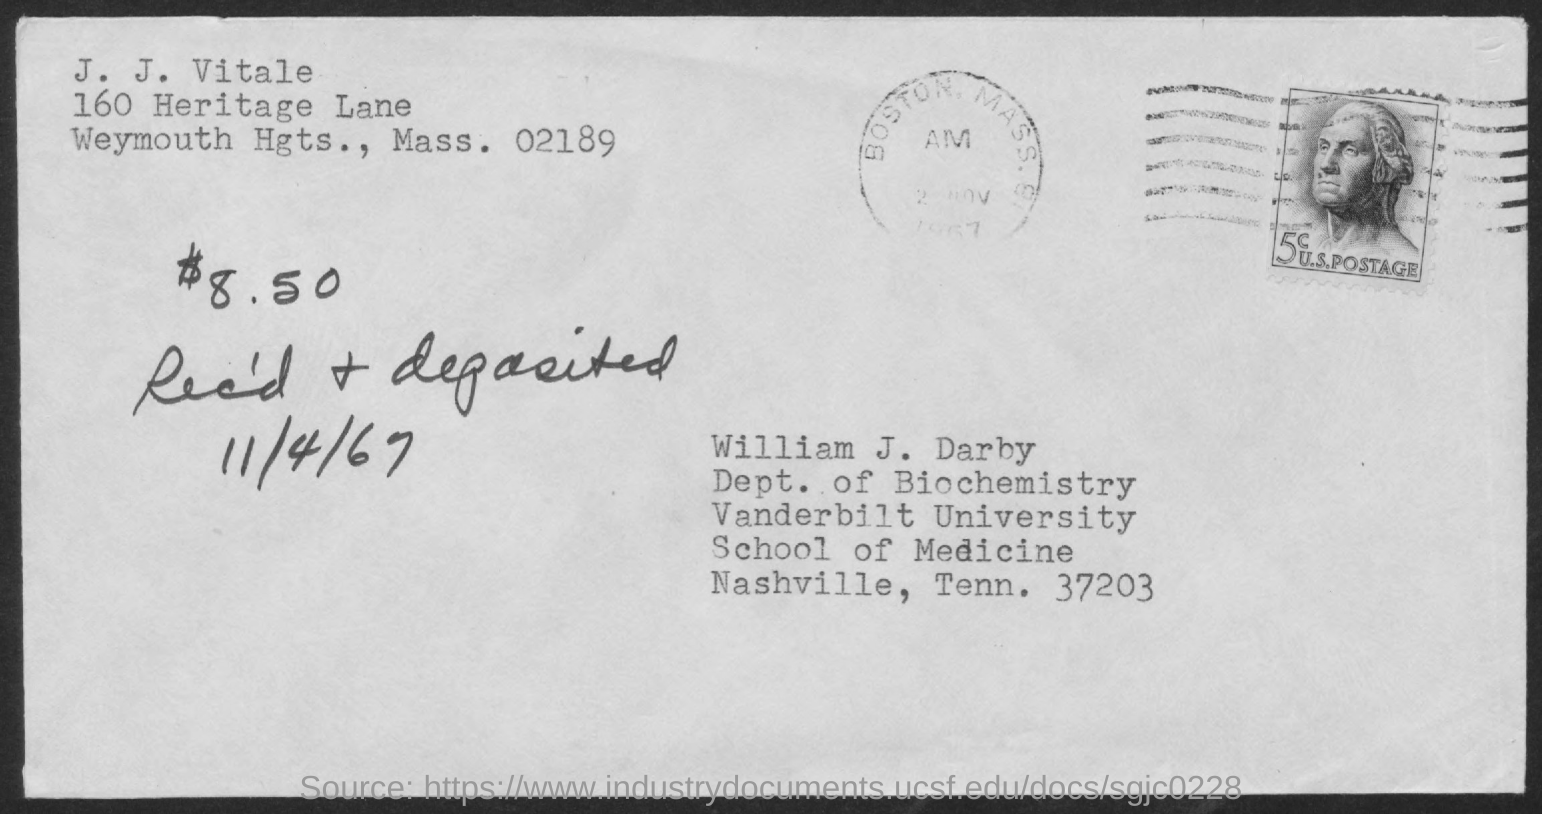What is the name of the person written in the top left corner?
Your answer should be compact. J. j. vitale. 